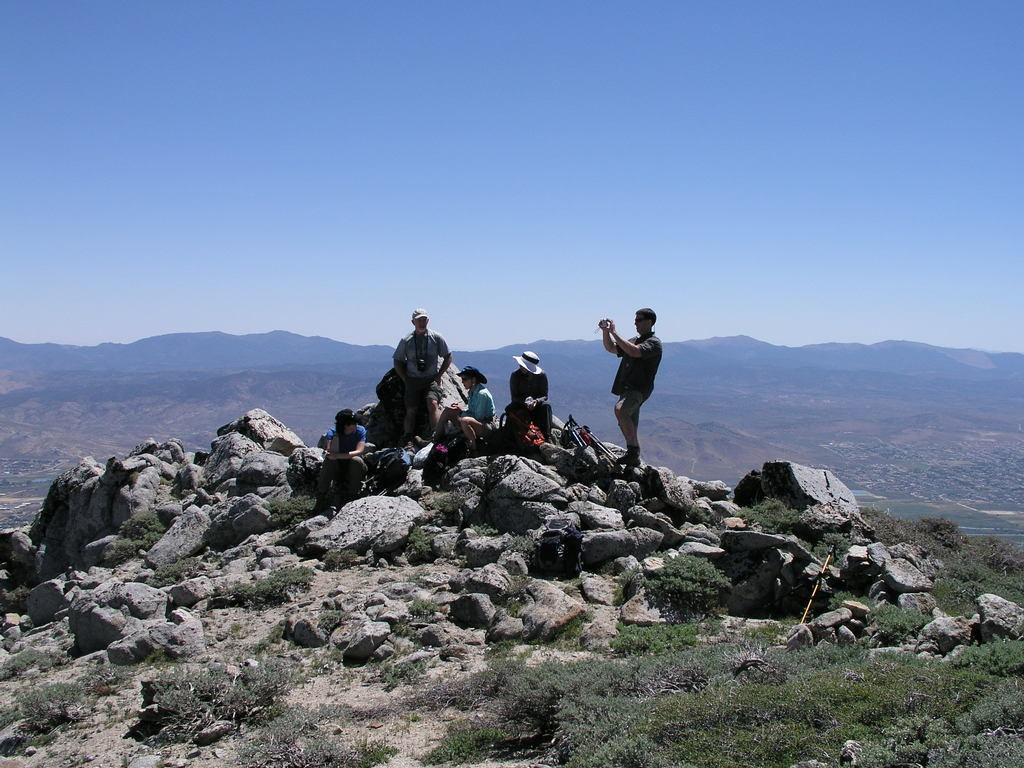What are the people in the image doing? The people in the image are sitting on rocks and standing. What can be seen in the background of the image? There are mountains and the sky visible in the background of the image. What type of vegetation is present at the bottom right of the image? There is grass on the bottom right of the image. What type of hat is the earth wearing in the image? There is no earth or hat present in the image. Can you describe the hook that is holding up the mountains in the image? There is no hook present in the image; the mountains are naturally standing. 